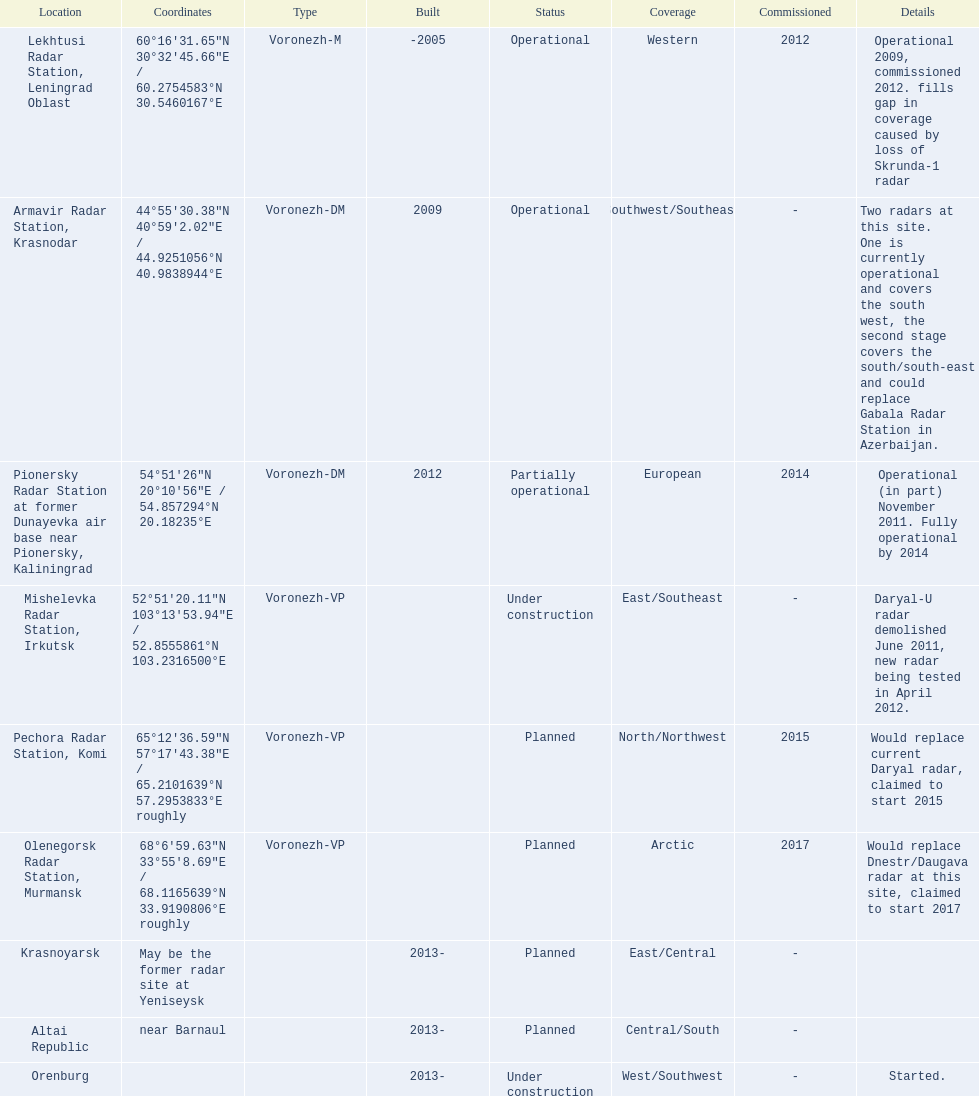What are the list of radar locations? Lekhtusi Radar Station, Leningrad Oblast, Armavir Radar Station, Krasnodar, Pionersky Radar Station at former Dunayevka air base near Pionersky, Kaliningrad, Mishelevka Radar Station, Irkutsk, Pechora Radar Station, Komi, Olenegorsk Radar Station, Murmansk, Krasnoyarsk, Altai Republic, Orenburg. Which of these are claimed to start in 2015? Pechora Radar Station, Komi. 